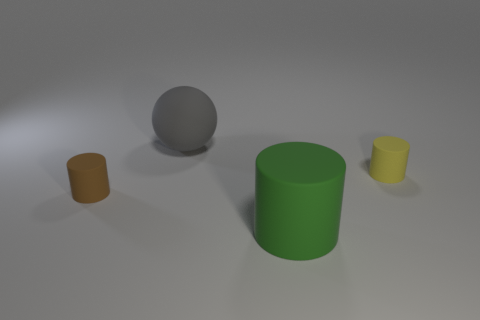Add 3 blue metallic cubes. How many objects exist? 7 Subtract all cylinders. How many objects are left? 1 Add 3 small brown matte cylinders. How many small brown matte cylinders exist? 4 Subtract 1 green cylinders. How many objects are left? 3 Subtract all large cubes. Subtract all large gray balls. How many objects are left? 3 Add 3 big gray balls. How many big gray balls are left? 4 